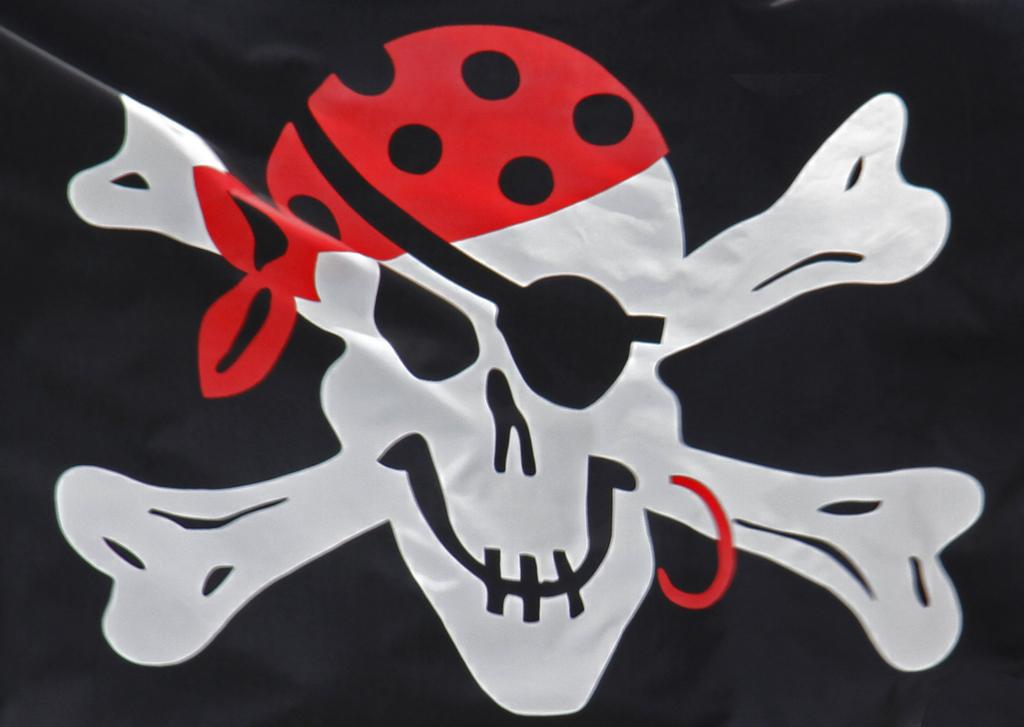What is the main object in the image? There is a flag in the image. What is depicted on the flag? The flag has a skull on it. What color is the cloth on the skull's head? The cloth on the skull's head is red. What is the color of the flag? The flag is in black color. What type of quince is being used to write the letters on the flag? There is no quince present in the image, and no letters are being written on the flag. 